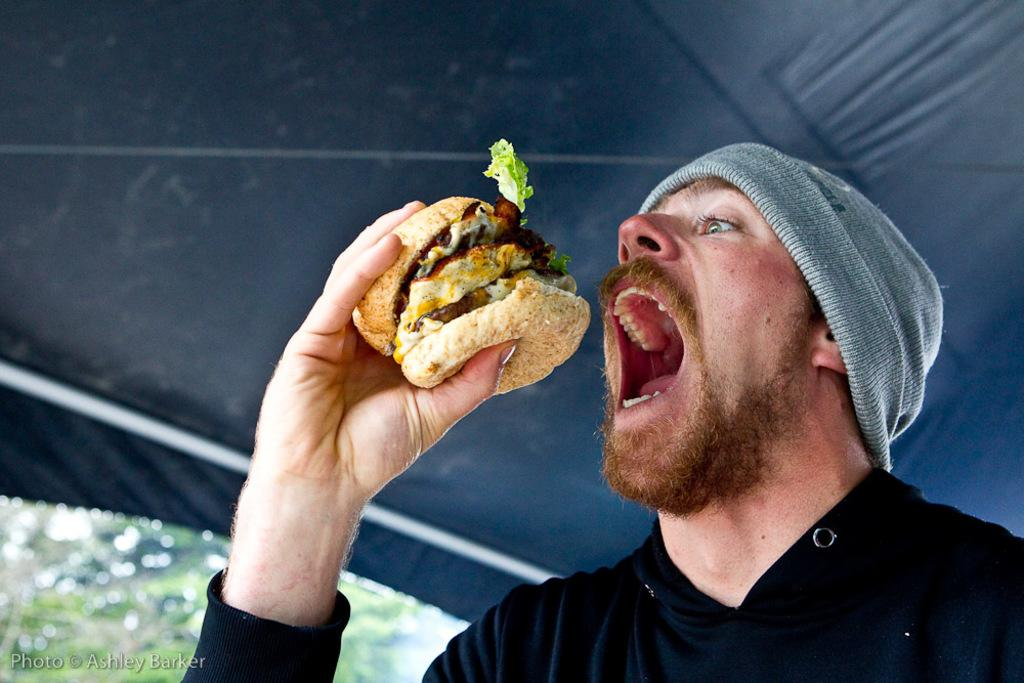Who is present in the image? There is a person in the image. What is the person doing in the image? The person is eating food items. Can you see any ducks causing trouble at home in the image? There are no ducks or any indication of trouble at home in the image. 